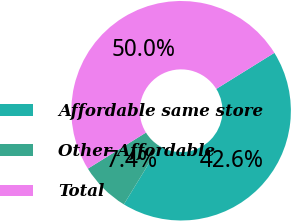<chart> <loc_0><loc_0><loc_500><loc_500><pie_chart><fcel>Affordable same store<fcel>Other Affordable<fcel>Total<nl><fcel>42.58%<fcel>7.42%<fcel>50.0%<nl></chart> 